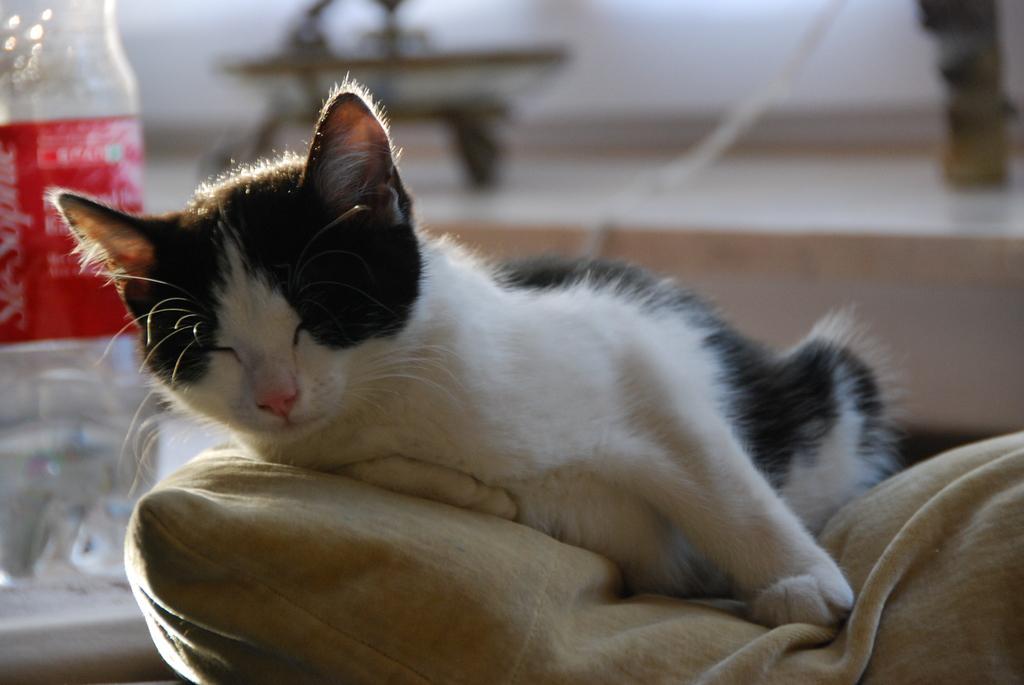Describe this image in one or two sentences. In the center of this picture there is a cat sleeping on an object. In the background we can see a bottle placed on the top of the table and the background of the image is blur and we can see some other objects. 